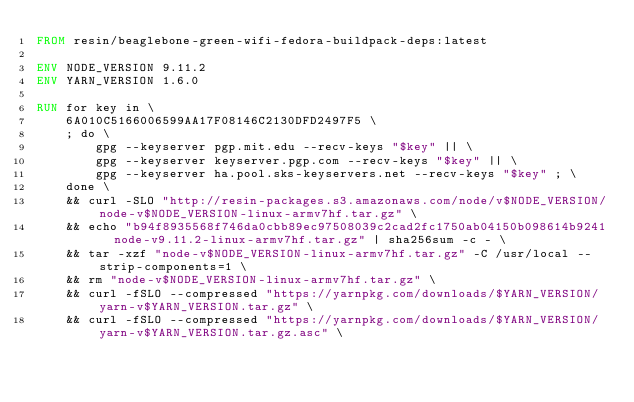<code> <loc_0><loc_0><loc_500><loc_500><_Dockerfile_>FROM resin/beaglebone-green-wifi-fedora-buildpack-deps:latest

ENV NODE_VERSION 9.11.2
ENV YARN_VERSION 1.6.0

RUN for key in \
	6A010C5166006599AA17F08146C2130DFD2497F5 \
	; do \
		gpg --keyserver pgp.mit.edu --recv-keys "$key" || \
		gpg --keyserver keyserver.pgp.com --recv-keys "$key" || \
		gpg --keyserver ha.pool.sks-keyservers.net --recv-keys "$key" ; \
	done \
	&& curl -SLO "http://resin-packages.s3.amazonaws.com/node/v$NODE_VERSION/node-v$NODE_VERSION-linux-armv7hf.tar.gz" \
	&& echo "b94f8935568f746da0cbb89ec97508039c2cad2fc1750ab04150b098614b9241  node-v9.11.2-linux-armv7hf.tar.gz" | sha256sum -c - \
	&& tar -xzf "node-v$NODE_VERSION-linux-armv7hf.tar.gz" -C /usr/local --strip-components=1 \
	&& rm "node-v$NODE_VERSION-linux-armv7hf.tar.gz" \
	&& curl -fSLO --compressed "https://yarnpkg.com/downloads/$YARN_VERSION/yarn-v$YARN_VERSION.tar.gz" \
	&& curl -fSLO --compressed "https://yarnpkg.com/downloads/$YARN_VERSION/yarn-v$YARN_VERSION.tar.gz.asc" \</code> 